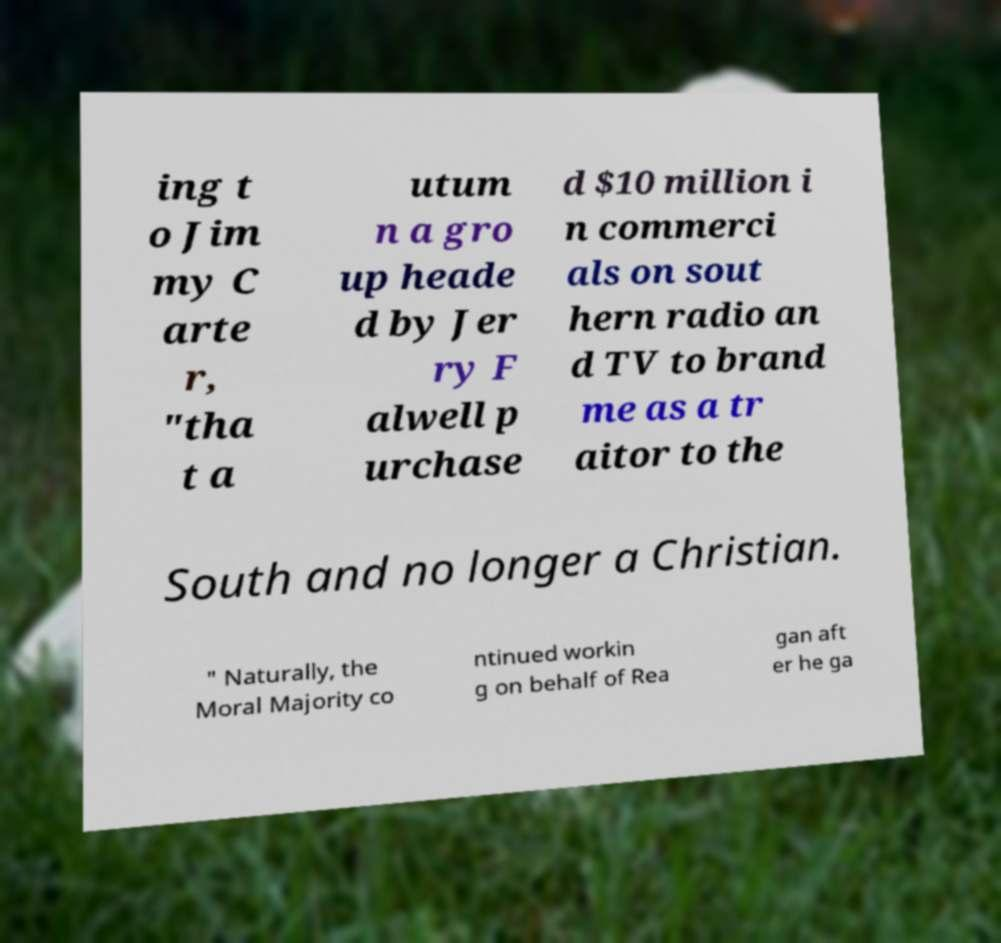Please identify and transcribe the text found in this image. ing t o Jim my C arte r, "tha t a utum n a gro up heade d by Jer ry F alwell p urchase d $10 million i n commerci als on sout hern radio an d TV to brand me as a tr aitor to the South and no longer a Christian. " Naturally, the Moral Majority co ntinued workin g on behalf of Rea gan aft er he ga 